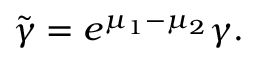Convert formula to latex. <formula><loc_0><loc_0><loc_500><loc_500>\tilde { \gamma } = e ^ { \mu _ { 1 } - \mu _ { 2 } } \gamma .</formula> 